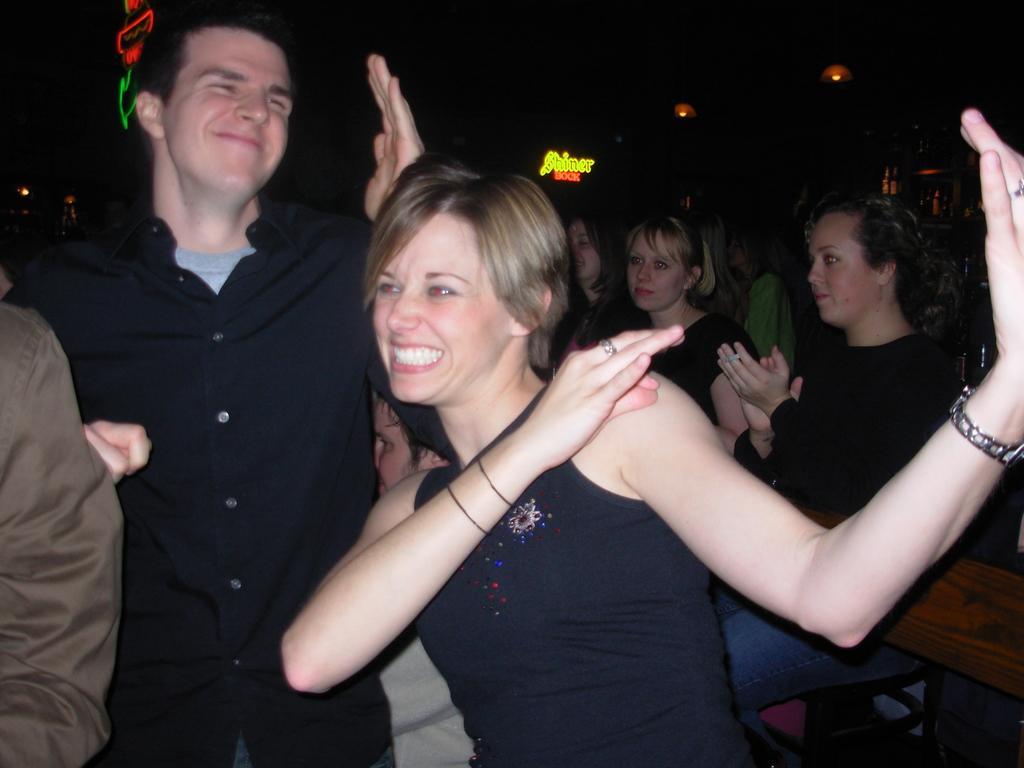Can you describe this image briefly? We can see people. Background it is dark and we can see lights and boards. 